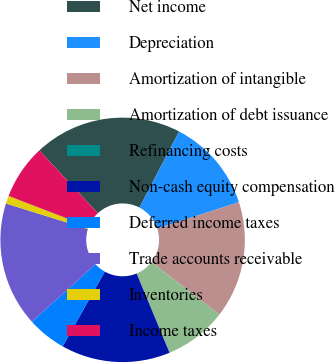Convert chart. <chart><loc_0><loc_0><loc_500><loc_500><pie_chart><fcel>Net income<fcel>Depreciation<fcel>Amortization of intangible<fcel>Amortization of debt issuance<fcel>Refinancing costs<fcel>Non-cash equity compensation<fcel>Deferred income taxes<fcel>Trade accounts receivable<fcel>Inventories<fcel>Income taxes<nl><fcel>19.58%<fcel>12.37%<fcel>15.46%<fcel>8.25%<fcel>0.01%<fcel>14.43%<fcel>5.16%<fcel>16.49%<fcel>1.04%<fcel>7.22%<nl></chart> 